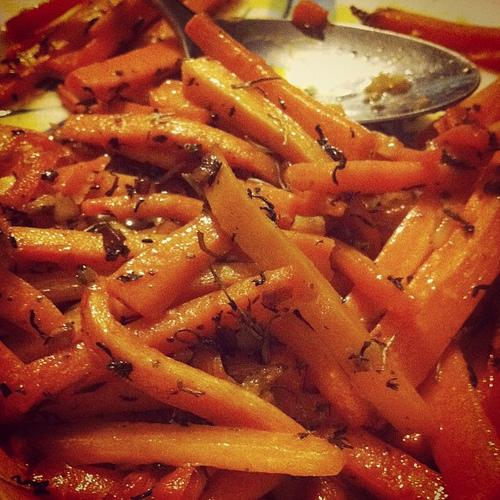Mention the most prominent element in the image and its most distinctive feature. The most prominent element is the cooked carrots, distinctively covered with herbs and seasoning. Describe the main focal point of the image and its surrounding elements. Cooked carrots covered with herbs are surrounded by an empty metal dish, silver spoon, and a variety of sliced carrots. Describe the primary plate of food in the image and the surrounding environment. A visually appealing plate of herb-covered carrots takes center stage, with sliced carrots and a silver spoon scattered around. In a casual tone, describe the most exciting element of the image and its key features. There's this awesome plate of carrots with herbs all over them, and a silver spoon just hangin' out nearby. Mention the main edible item in the image and a secondary element related to it. A plate of herb-seasoned carrots dominates the scene, with a silver spoon for eating the tasty concoction close by. Summarize the image's content, focusing on the arrangement of the elements. The image showcases a plate of herb-seasoned carrots amidst sliced carrots, an empty dish, and a silver spoon. Detail the central object in the image and its specific visual characteristics. The central object is a plate of cooked carrots, cut into large pieces and covered with aromatic herbs and seasonings. Explain the primary culinary dish in the image and a utensil included within the scene. The main dish is a plate of cooked carrots covered with herbs, and a silver spoon is present for eating purposes. Provide a brief overview of the main elements in the image. A variety of cooked and seasoned carrots, including some with herbs, are arranged next to an empty metal dish and a silver spoon. In a creative manner, describe the main subject of the image and a secondary element. A tantalizing plate of herb-covered carrots steals the limelight while a humble empty metal dish quietly waits for its turn. 